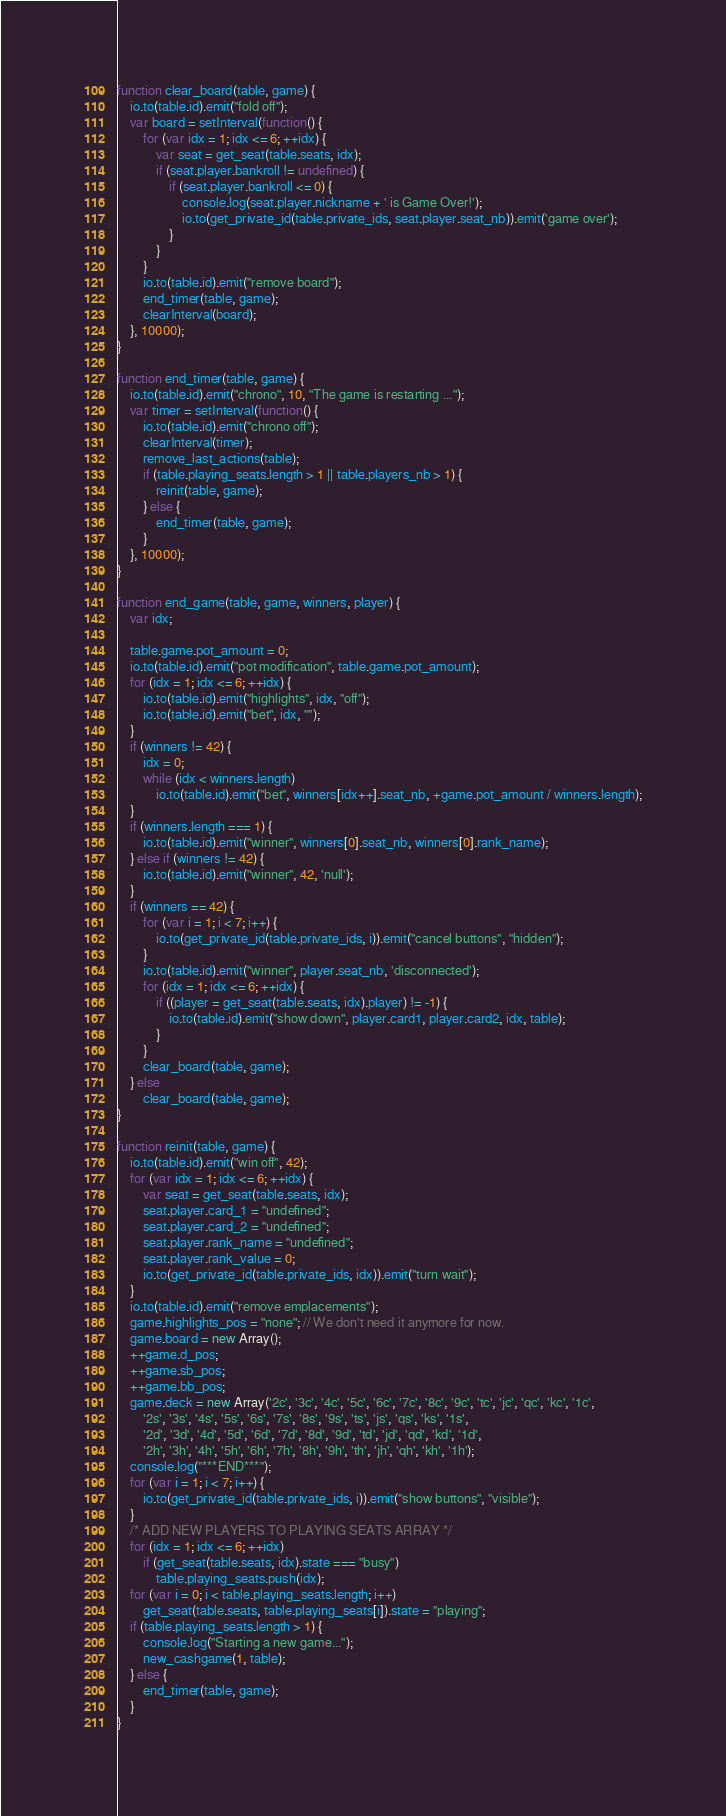<code> <loc_0><loc_0><loc_500><loc_500><_JavaScript_>function clear_board(table, game) {
    io.to(table.id).emit("fold off");
    var board = setInterval(function() {
        for (var idx = 1; idx <= 6; ++idx) {
            var seat = get_seat(table.seats, idx);
            if (seat.player.bankroll != undefined) {
                if (seat.player.bankroll <= 0) {
                    console.log(seat.player.nickname + ' is Game Over!');
                    io.to(get_private_id(table.private_ids, seat.player.seat_nb)).emit('game over');
                }
            }
        }
        io.to(table.id).emit("remove board");
        end_timer(table, game);
        clearInterval(board);
    }, 10000);
}

function end_timer(table, game) {
    io.to(table.id).emit("chrono", 10, "The game is restarting ...");
    var timer = setInterval(function() {
        io.to(table.id).emit("chrono off");
        clearInterval(timer);
        remove_last_actions(table);
        if (table.playing_seats.length > 1 || table.players_nb > 1) {
            reinit(table, game);
        } else {
            end_timer(table, game);
        }
    }, 10000);
}

function end_game(table, game, winners, player) {
    var idx;

    table.game.pot_amount = 0;
    io.to(table.id).emit("pot modification", table.game.pot_amount);
    for (idx = 1; idx <= 6; ++idx) {
        io.to(table.id).emit("highlights", idx, "off");
        io.to(table.id).emit("bet", idx, "");
    }
    if (winners != 42) {
        idx = 0;
        while (idx < winners.length)
            io.to(table.id).emit("bet", winners[idx++].seat_nb, +game.pot_amount / winners.length);
    }
    if (winners.length === 1) {
        io.to(table.id).emit("winner", winners[0].seat_nb, winners[0].rank_name);
    } else if (winners != 42) {
        io.to(table.id).emit("winner", 42, 'null');
    }
    if (winners == 42) {
        for (var i = 1; i < 7; i++) {
            io.to(get_private_id(table.private_ids, i)).emit("cancel buttons", "hidden");
        }
        io.to(table.id).emit("winner", player.seat_nb, 'disconnected');
        for (idx = 1; idx <= 6; ++idx) {
            if ((player = get_seat(table.seats, idx).player) != -1) {
                io.to(table.id).emit("show down", player.card1, player.card2, idx, table);
            }
        }
        clear_board(table, game);
    } else
        clear_board(table, game);
}

function reinit(table, game) {
	io.to(table.id).emit("win off", 42);
    for (var idx = 1; idx <= 6; ++idx) {
        var seat = get_seat(table.seats, idx);
        seat.player.card_1 = "undefined";
        seat.player.card_2 = "undefined";
        seat.player.rank_name = "undefined";
        seat.player.rank_value = 0;
        io.to(get_private_id(table.private_ids, idx)).emit("turn wait");
    }
    io.to(table.id).emit("remove emplacements");
    game.highlights_pos = "none"; // We don't need it anymore for now.
    game.board = new Array();
    ++game.d_pos;
    ++game.sb_pos;
    ++game.bb_pos;
    game.deck = new Array('2c', '3c', '4c', '5c', '6c', '7c', '8c', '9c', 'tc', 'jc', 'qc', 'kc', '1c',
        '2s', '3s', '4s', '5s', '6s', '7s', '8s', '9s', 'ts', 'js', 'qs', 'ks', '1s',
        '2d', '3d', '4d', '5d', '6d', '7d', '8d', '9d', 'td', 'jd', 'qd', 'kd', '1d',
        '2h', '3h', '4h', '5h', '6h', '7h', '8h', '9h', 'th', 'jh', 'qh', 'kh', '1h');
    console.log("***END***");
    for (var i = 1; i < 7; i++) {
        io.to(get_private_id(table.private_ids, i)).emit("show buttons", "visible");
    }
    /* ADD NEW PLAYERS TO PLAYING SEATS ARRAY */
    for (idx = 1; idx <= 6; ++idx)
        if (get_seat(table.seats, idx).state === "busy")
            table.playing_seats.push(idx);
    for (var i = 0; i < table.playing_seats.length; i++)
        get_seat(table.seats, table.playing_seats[i]).state = "playing";
    if (table.playing_seats.length > 1) {
        console.log("Starting a new game...");
        new_cashgame(1, table);
    } else {
        end_timer(table, game);
	}
}
</code> 